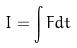<formula> <loc_0><loc_0><loc_500><loc_500>I = \int F d t</formula> 